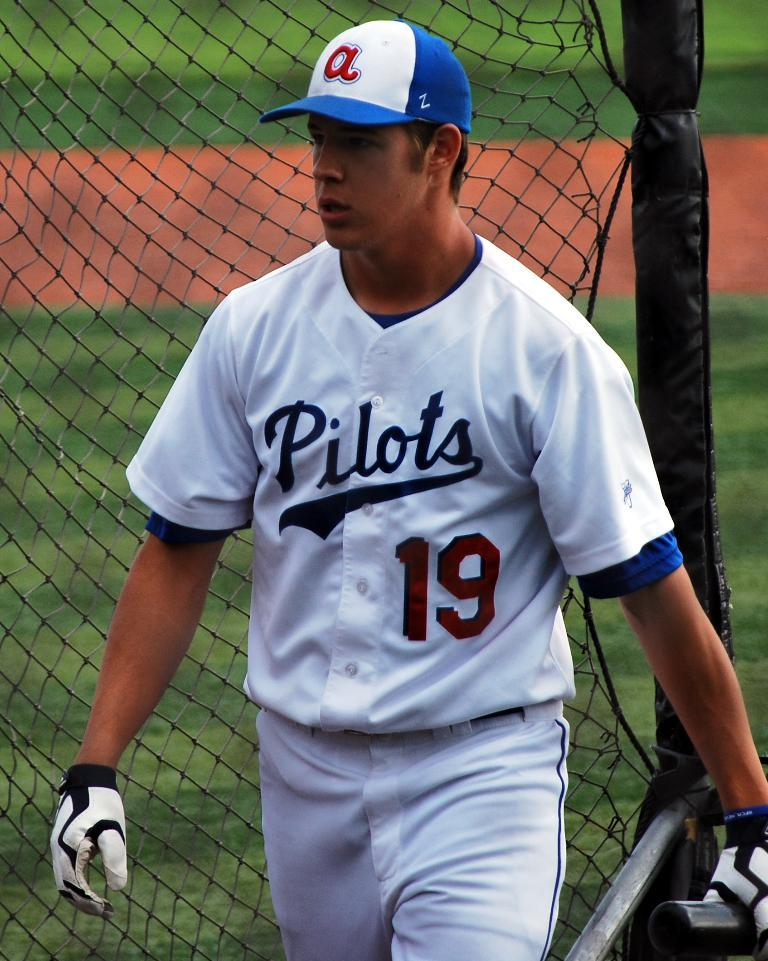<image>
Share a concise interpretation of the image provided. a shirt on a player with the word Pilots on it 